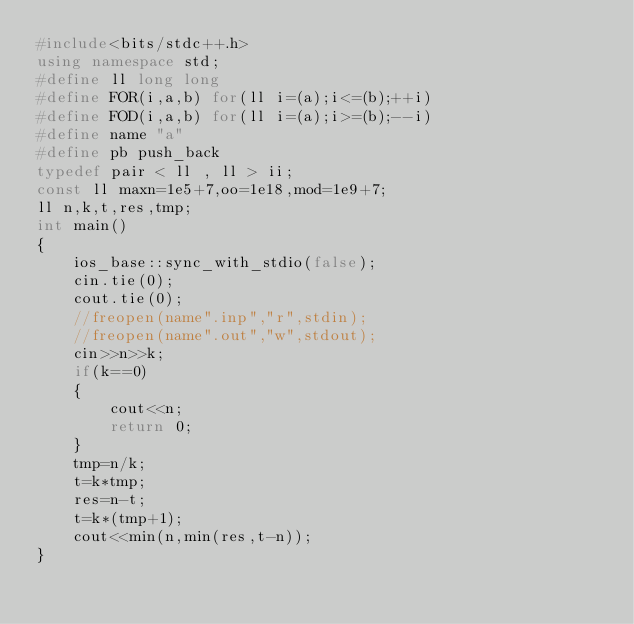<code> <loc_0><loc_0><loc_500><loc_500><_C++_>#include<bits/stdc++.h>
using namespace std;
#define ll long long
#define FOR(i,a,b) for(ll i=(a);i<=(b);++i)
#define FOD(i,a,b) for(ll i=(a);i>=(b);--i)
#define name "a"
#define pb push_back
typedef pair < ll , ll > ii;
const ll maxn=1e5+7,oo=1e18,mod=1e9+7;
ll n,k,t,res,tmp;
int main()
{
    ios_base::sync_with_stdio(false);
    cin.tie(0);
    cout.tie(0);
    //freopen(name".inp","r",stdin);
    //freopen(name".out","w",stdout);
    cin>>n>>k;
    if(k==0)
    {
        cout<<n;
        return 0;
    }
    tmp=n/k;
    t=k*tmp;
    res=n-t;
    t=k*(tmp+1);
    cout<<min(n,min(res,t-n));
}
</code> 